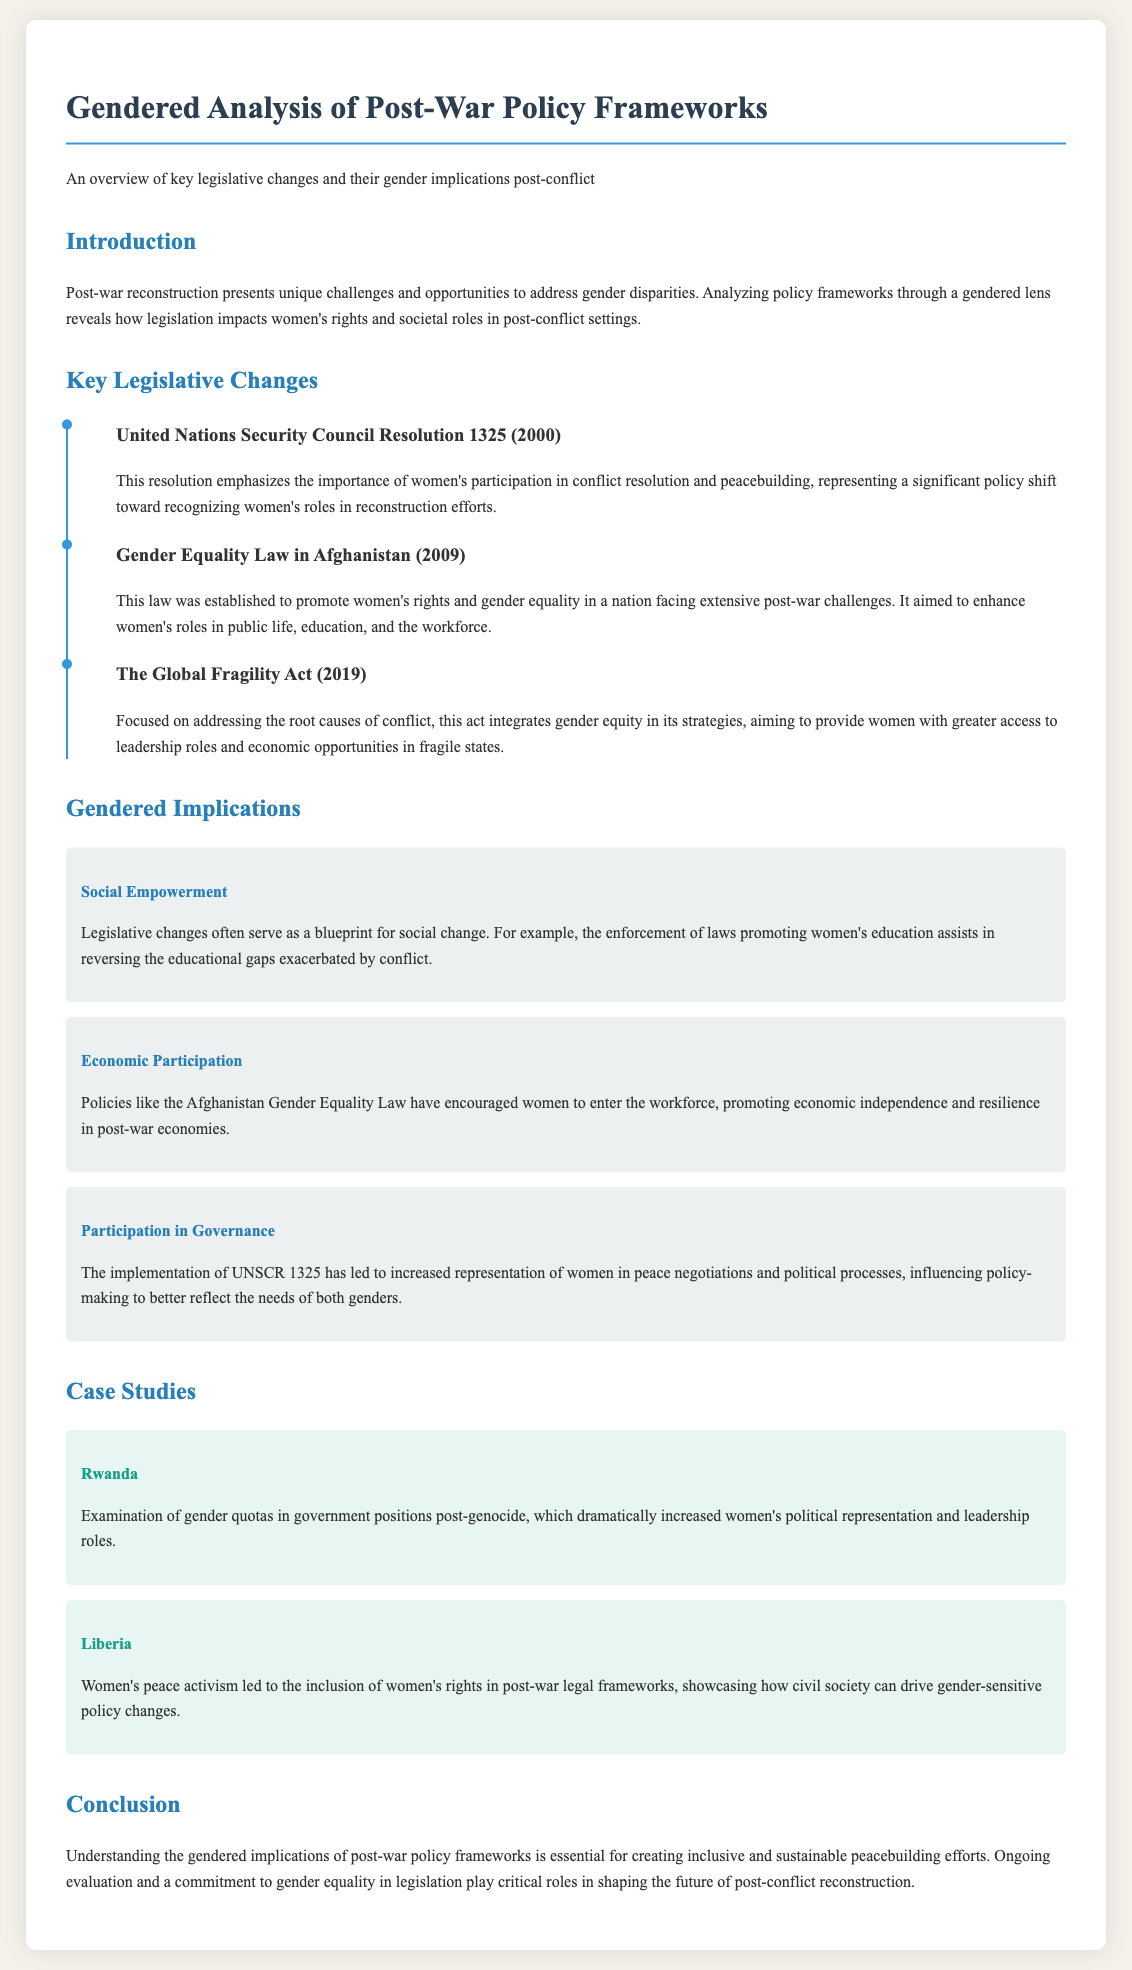What is the title of the document? The title provides the main subject of the document, which summarizes its focus on gender analysis within post-war policy frameworks.
Answer: Gendered Analysis of Post-War Policy Frameworks What does UNSCR stand for? This acronym is mentioned in relation to the resolution promoting women's participation in peacebuilding, reflecting its full title.
Answer: United Nations Security Council Resolution When was the Gender Equality Law in Afghanistan established? The date of this law is significant as it marks a formal step towards promoting women's rights in Afghanistan post-war.
Answer: 2009 What is one of the gendered implications mentioned in the document? The document highlights various implications of policy changes; one specific area of focus is mentioned in this section.
Answer: Social Empowerment Which country is associated with increased women's political representation after a genocide? The document provides a specific case study that exemplifies the impact of gender quotas in government legislation.
Answer: Rwanda What is the focus of The Global Fragility Act? This act aims to address the underlying issues that cause conflict and incorporates gender equity into its strategic frameworks.
Answer: Root causes of conflict What does the case study for Liberia highlight? This case study illustrates the influence of women's activism on the integration of rights into legal frameworks post-conflict.
Answer: Women's peace activism What is the concluding statement about the importance of gendered implications? The conclusion emphasizes a broader perspective on the role of understanding gender disparities for future policies.
Answer: Essential for creating inclusive and sustainable peacebuilding efforts 